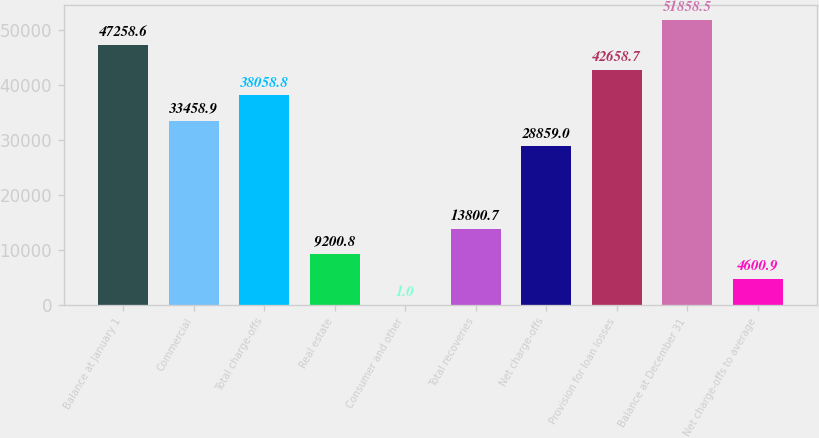Convert chart. <chart><loc_0><loc_0><loc_500><loc_500><bar_chart><fcel>Balance at January 1<fcel>Commercial<fcel>Total charge-offs<fcel>Real estate<fcel>Consumer and other<fcel>Total recoveries<fcel>Net charge-offs<fcel>Provision for loan losses<fcel>Balance at December 31<fcel>Net charge-offs to average<nl><fcel>47258.6<fcel>33458.9<fcel>38058.8<fcel>9200.8<fcel>1<fcel>13800.7<fcel>28859<fcel>42658.7<fcel>51858.5<fcel>4600.9<nl></chart> 